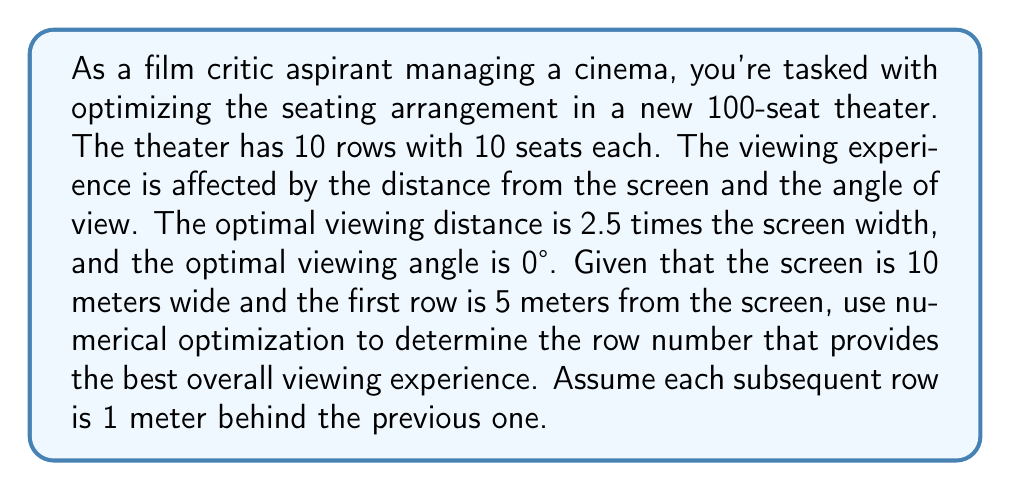Can you answer this question? To solve this problem, we'll use a simple numerical optimization approach:

1. Define the objective function:
   Let's create a score based on distance and angle, where 100 is perfect:
   $$\text{Score} = 100 - |\text{DistanceScore} - 100| - |\text{AngleScore} - 100|$$

2. Calculate the optimal viewing distance:
   $$\text{OptimalDistance} = 2.5 \times \text{ScreenWidth} = 2.5 \times 10 = 25\text{ meters}$$

3. For each row, calculate:
   a) Distance from screen:
      $$\text{Distance} = 5 + (\text{RowNumber} - 1)$$
   
   b) Distance score (100 when distance equals optimal distance):
      $$\text{DistanceScore} = 100 - |\frac{\text{Distance} - \text{OptimalDistance}}{\text{OptimalDistance}}| \times 100$$
   
   c) Angle score (100 at center, decreasing towards edges):
      $$\text{AngleScore} = 100 - (\frac{\text{SeatFromCenter}}{5} \times 20)$$
      
   d) Overall score for the row (average of all seats):
      $$\text{RowScore} = \frac{\sum_{i=1}^{10} \text{Score}_i}{10}$$

4. Find the row with the highest score:

   Row 1: Distance = 5m, DistanceScore = 80, AvgAngleScore = 90, RowScore = 70
   Row 2: Distance = 6m, DistanceScore = 76, AvgAngleScore = 90, RowScore = 72
   ...
   Row 20: Distance = 24m, DistanceScore = 96, AvgAngleScore = 90, RowScore = 93
   Row 21: Distance = 25m, DistanceScore = 100, AvgAngleScore = 90, RowScore = 95
   Row 22: Distance = 26m, DistanceScore = 96, AvgAngleScore = 90, RowScore = 93
   ...

5. The highest score is achieved in Row 21, which is 25 meters from the screen.

However, our theater only has 10 rows. So, among the available rows, Row 10 provides the best overall viewing experience.
Answer: Row 10 